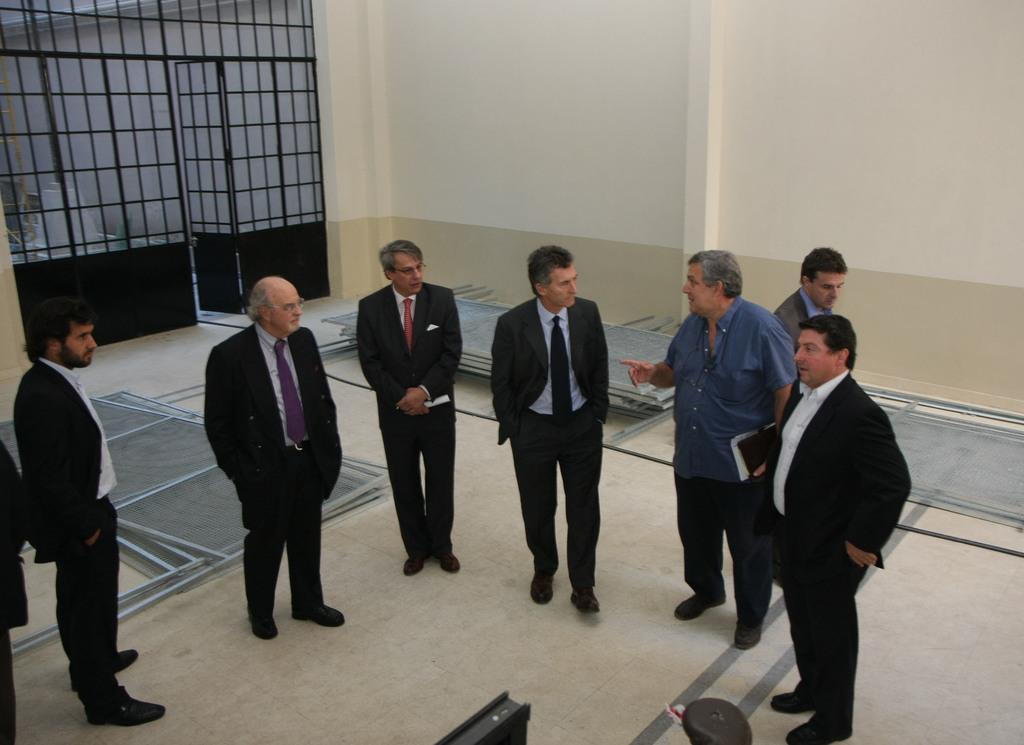How many people are in the image? There are a few people in the image. What can be seen beneath the people's feet in the image? The ground is visible in the image. What is present on the ground in the image? There are objects on the ground. What is located at the back of the image? There is a wall in the image. What type of architectural feature is present in the image? There are gates in the image. What is visible at the bottom of the image? There are objects at the bottom of the image. What language are the people speaking in the image? The provided facts do not mention any language spoken by the people in the image. What type of hair can be seen on the people in the image? The provided facts do not mention any specific hairstyles or hair types of the people in the image. 